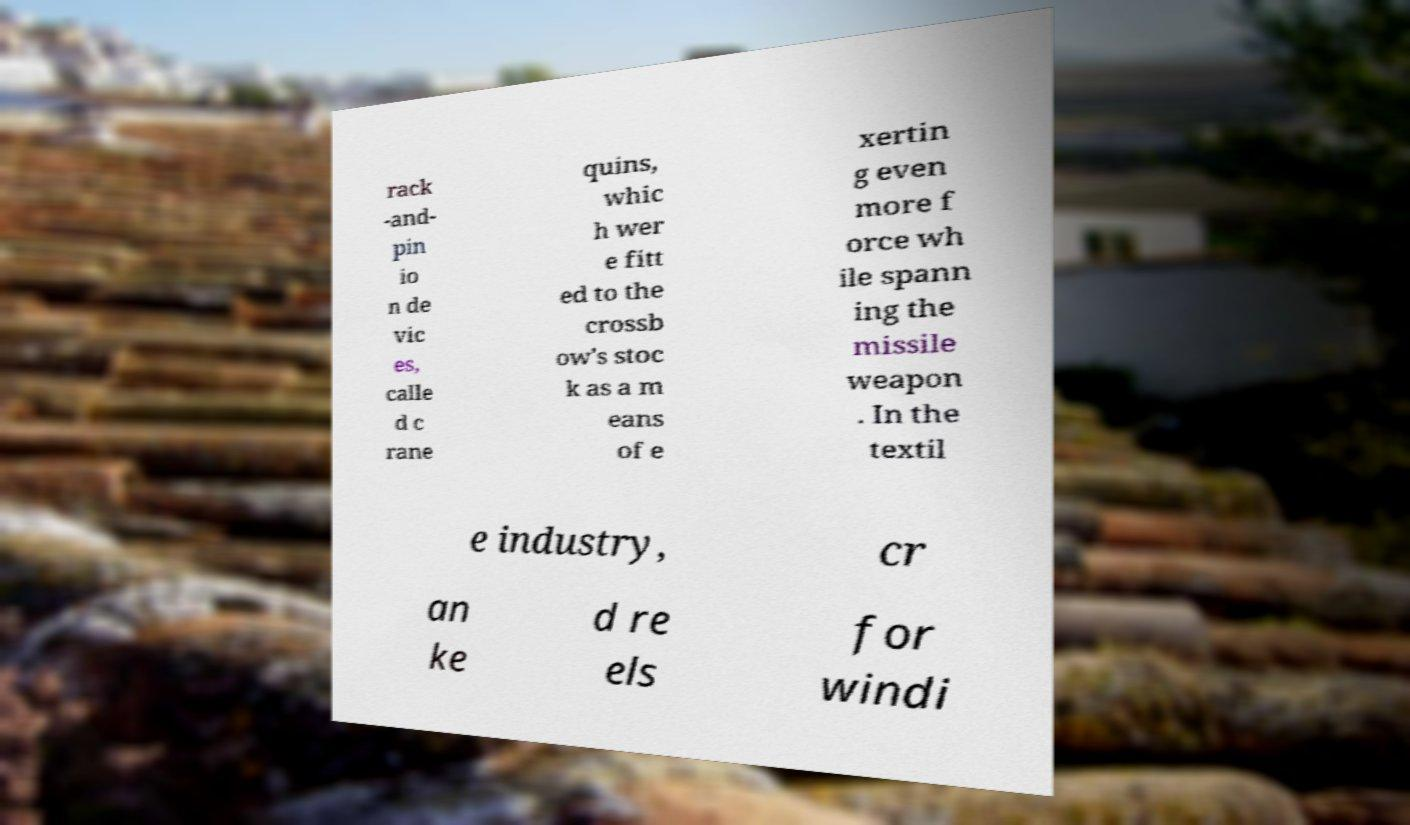There's text embedded in this image that I need extracted. Can you transcribe it verbatim? rack -and- pin io n de vic es, calle d c rane quins, whic h wer e fitt ed to the crossb ow's stoc k as a m eans of e xertin g even more f orce wh ile spann ing the missile weapon . In the textil e industry, cr an ke d re els for windi 